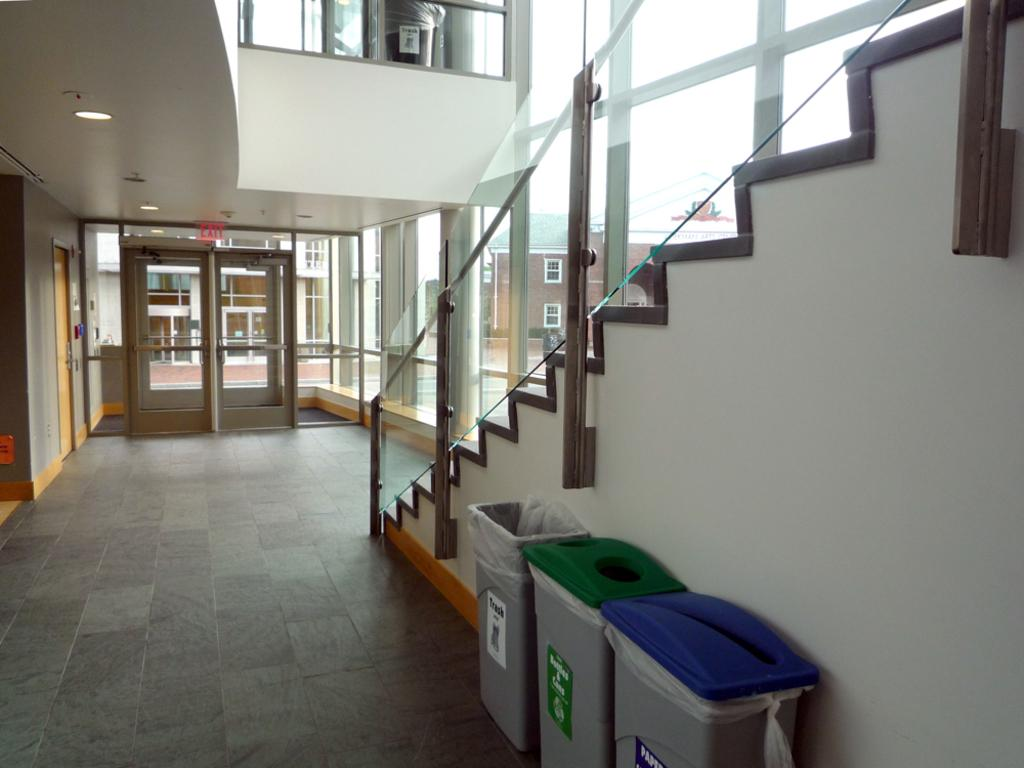What is visible on the ground in the image? The floor is visible in the image. What objects are present for waste disposal in the image? There are dustbins in the image. What architectural feature allows for vertical movement in the image? There are stairs in the image. What safety feature is present near the stairs in the image? Railing is present in the image. What type of door can be seen in the image? A glass door is visible in the image. What type of structure is present in the background of the image? There is a wall in the image. Can you see a bridge in the image? There is no bridge present in the image. 